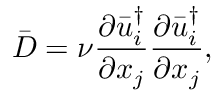<formula> <loc_0><loc_0><loc_500><loc_500>\bar { D } = \nu \frac { { \partial \bar { u } _ { i } ^ { \dag } } } { { \partial { x _ { j } } } } \frac { { \partial \bar { u } _ { i } ^ { \dag } } } { { \partial { x _ { j } } } } ,</formula> 